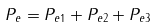<formula> <loc_0><loc_0><loc_500><loc_500>P _ { e } = P _ { e 1 } + P _ { e 2 } + P _ { e 3 }</formula> 